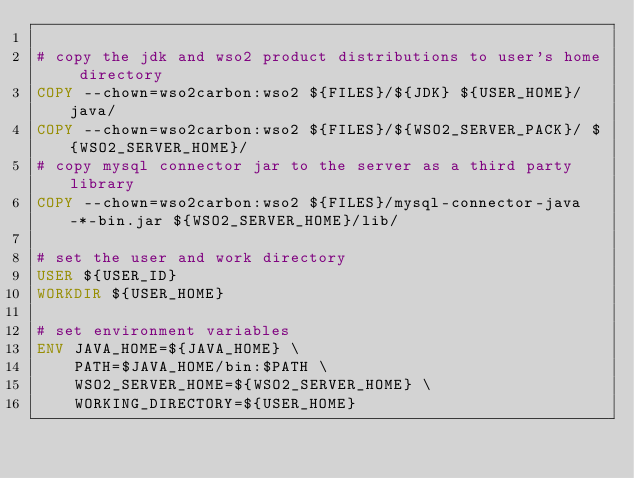Convert code to text. <code><loc_0><loc_0><loc_500><loc_500><_Dockerfile_>
# copy the jdk and wso2 product distributions to user's home directory
COPY --chown=wso2carbon:wso2 ${FILES}/${JDK} ${USER_HOME}/java/
COPY --chown=wso2carbon:wso2 ${FILES}/${WSO2_SERVER_PACK}/ ${WSO2_SERVER_HOME}/
# copy mysql connector jar to the server as a third party library
COPY --chown=wso2carbon:wso2 ${FILES}/mysql-connector-java-*-bin.jar ${WSO2_SERVER_HOME}/lib/

# set the user and work directory
USER ${USER_ID}
WORKDIR ${USER_HOME}

# set environment variables
ENV JAVA_HOME=${JAVA_HOME} \
    PATH=$JAVA_HOME/bin:$PATH \
    WSO2_SERVER_HOME=${WSO2_SERVER_HOME} \
    WORKING_DIRECTORY=${USER_HOME}
</code> 